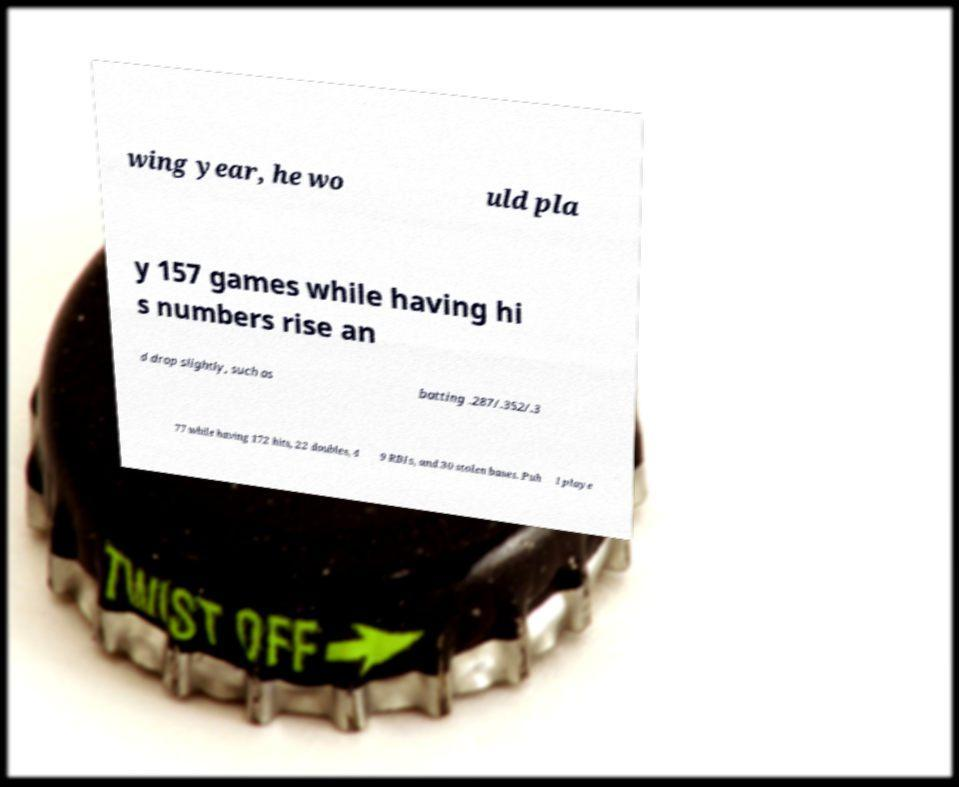Could you extract and type out the text from this image? wing year, he wo uld pla y 157 games while having hi s numbers rise an d drop slightly, such as batting .287/.352/.3 77 while having 172 hits, 22 doubles, 4 9 RBIs, and 30 stolen bases. Puh l playe 